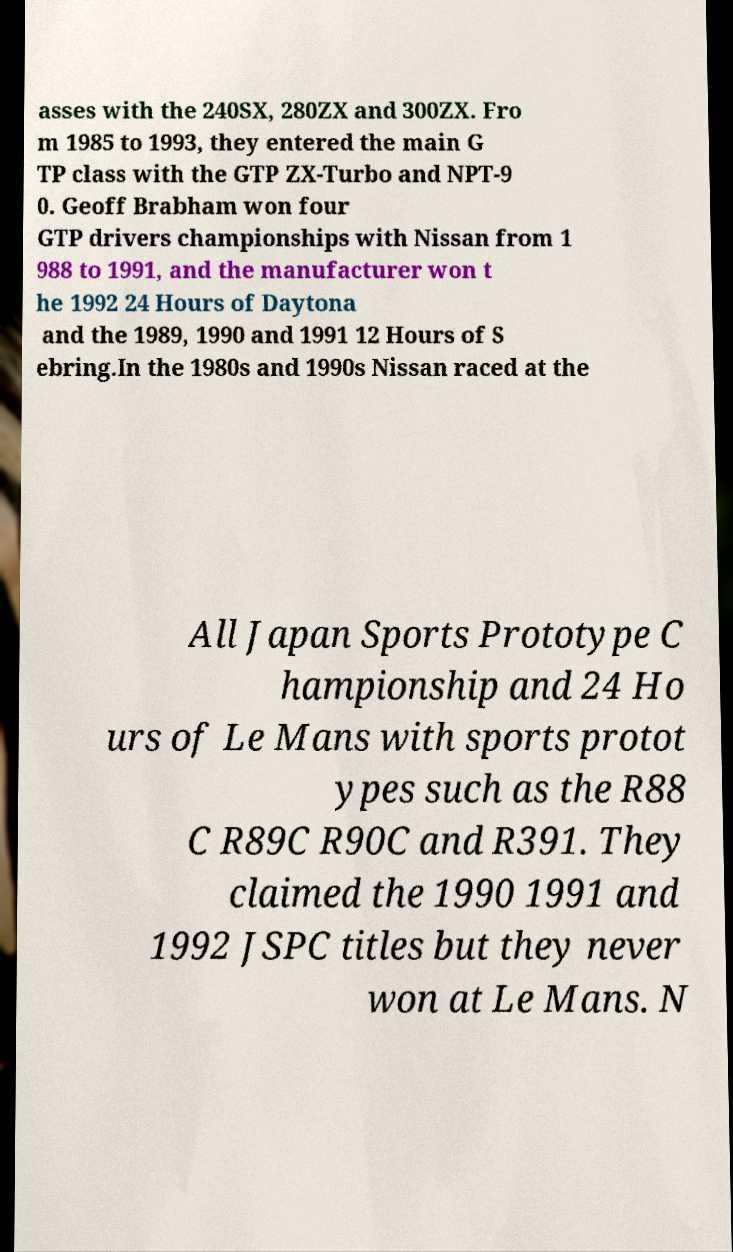For documentation purposes, I need the text within this image transcribed. Could you provide that? asses with the 240SX, 280ZX and 300ZX. Fro m 1985 to 1993, they entered the main G TP class with the GTP ZX-Turbo and NPT-9 0. Geoff Brabham won four GTP drivers championships with Nissan from 1 988 to 1991, and the manufacturer won t he 1992 24 Hours of Daytona and the 1989, 1990 and 1991 12 Hours of S ebring.In the 1980s and 1990s Nissan raced at the All Japan Sports Prototype C hampionship and 24 Ho urs of Le Mans with sports protot ypes such as the R88 C R89C R90C and R391. They claimed the 1990 1991 and 1992 JSPC titles but they never won at Le Mans. N 